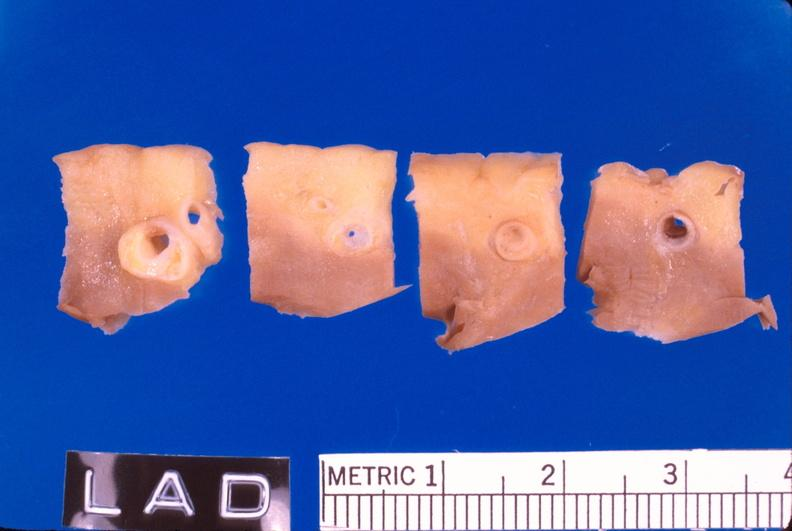where is this?
Answer the question using a single word or phrase. Vasculature 